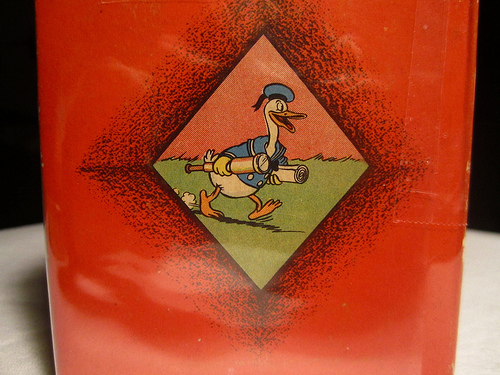<image>
Can you confirm if the telescope is behind the hat? No. The telescope is not behind the hat. From this viewpoint, the telescope appears to be positioned elsewhere in the scene. 